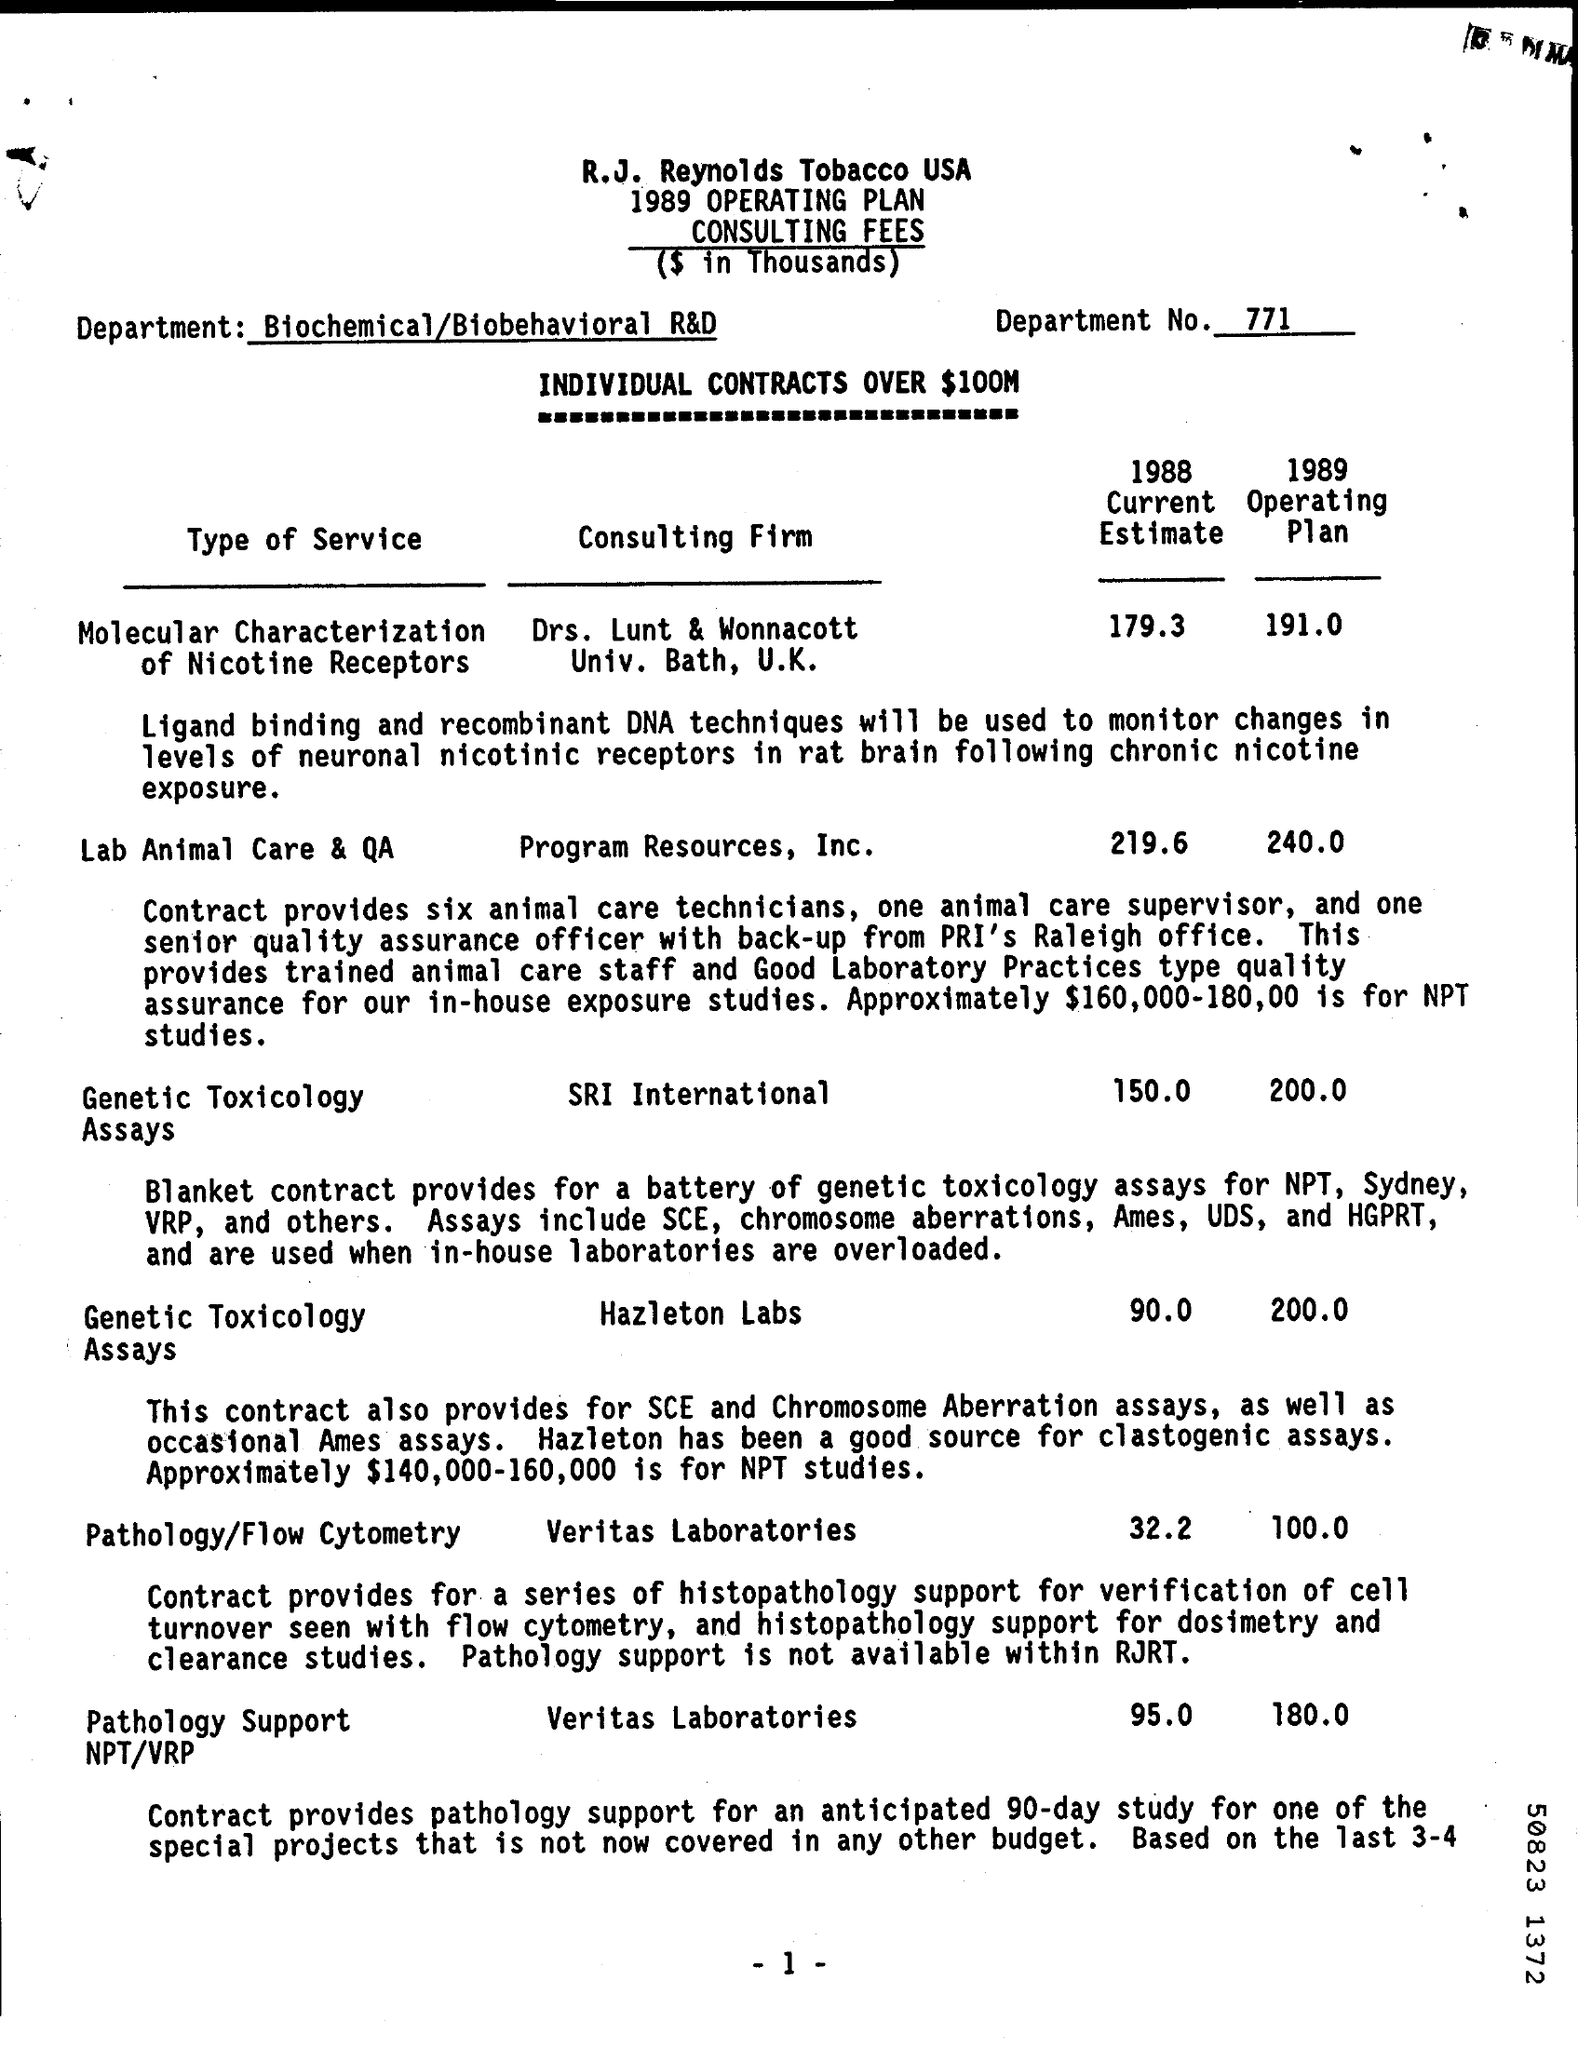Give some essential details in this illustration. ​ The department responsible for this research and development is Biochemical/Biobehavioral R&D. The department number is 771... SRI International is the consulting firm that specializes in genetic toxicology assays. 